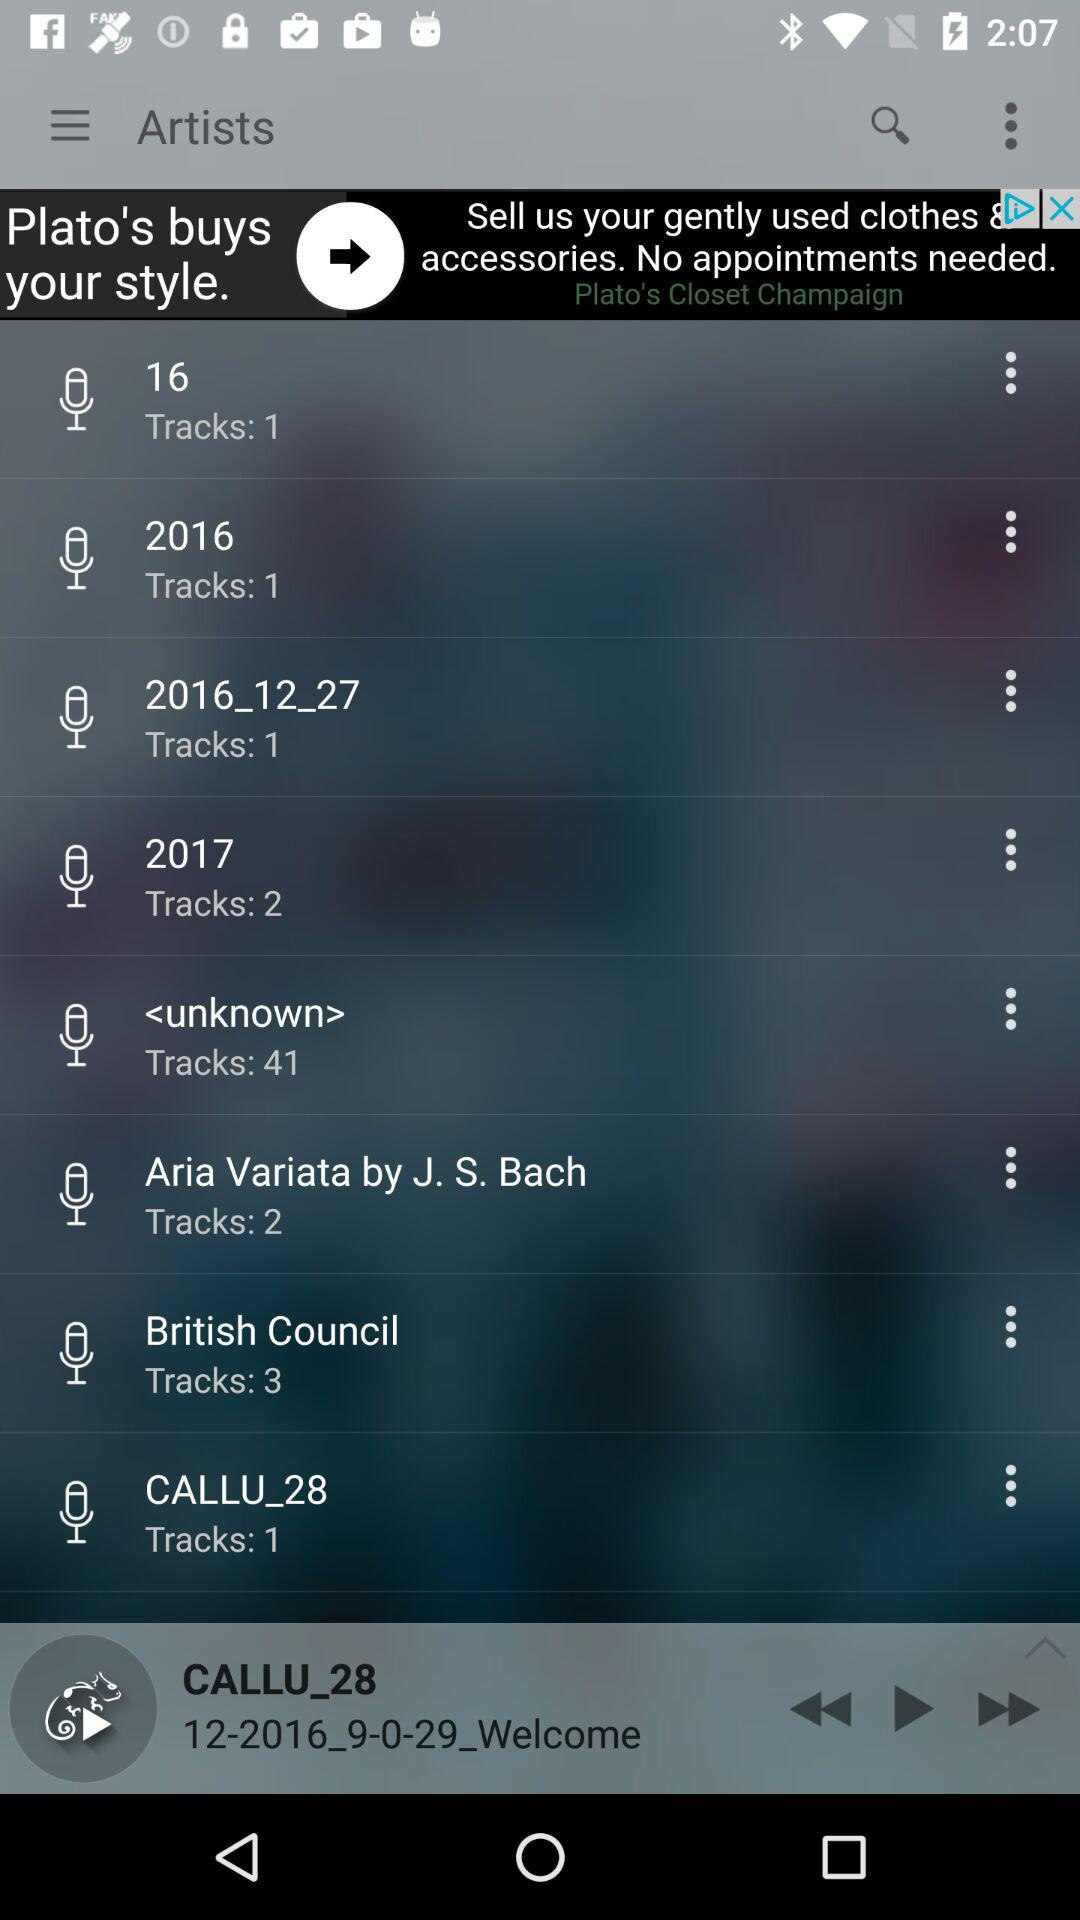What song was last played? The last played song was "CALLU_28". 